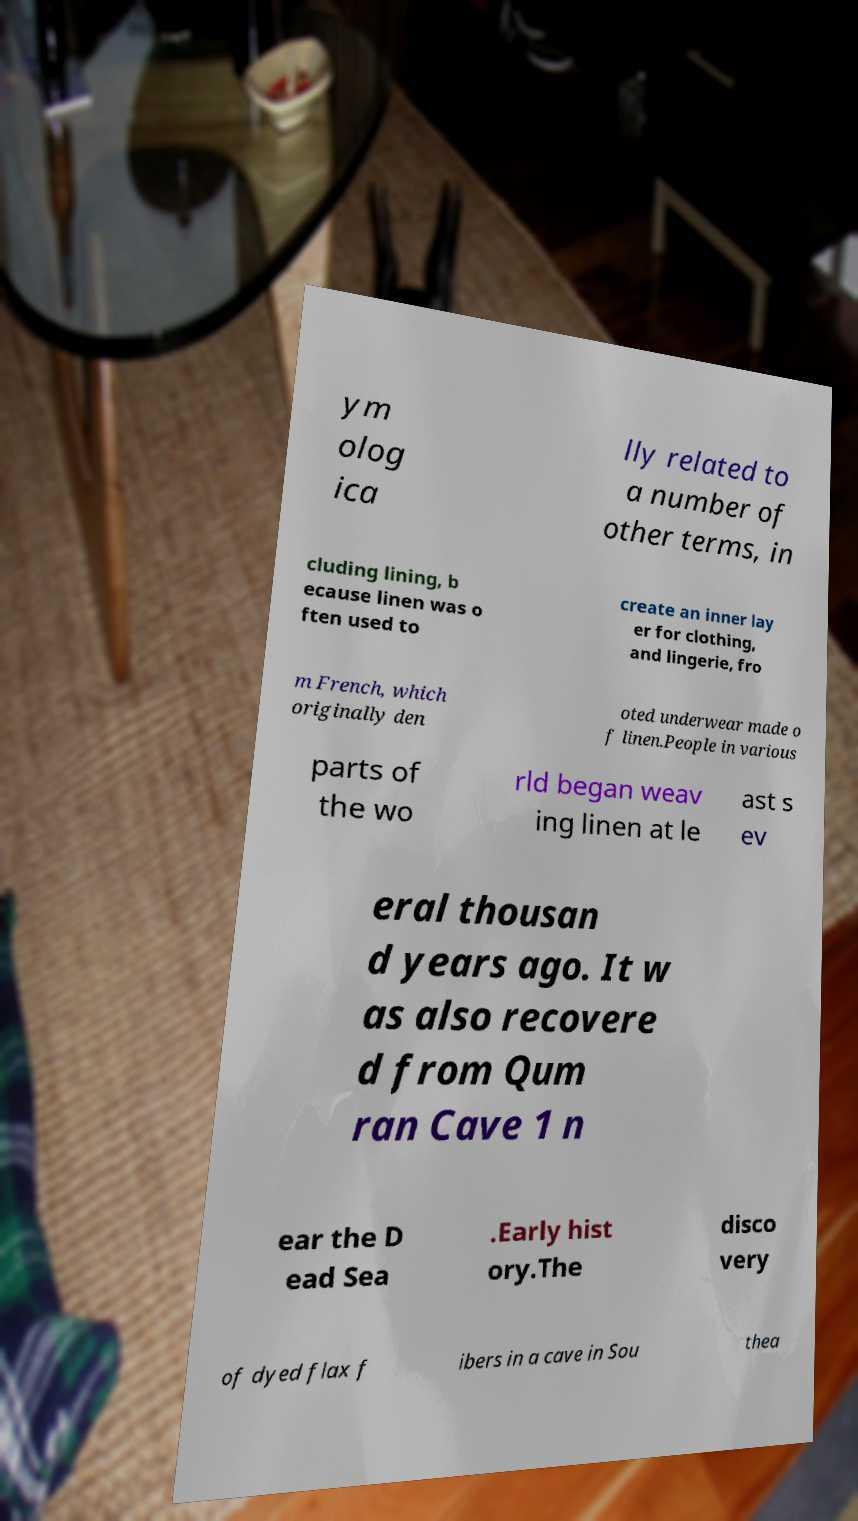Could you extract and type out the text from this image? ym olog ica lly related to a number of other terms, in cluding lining, b ecause linen was o ften used to create an inner lay er for clothing, and lingerie, fro m French, which originally den oted underwear made o f linen.People in various parts of the wo rld began weav ing linen at le ast s ev eral thousan d years ago. It w as also recovere d from Qum ran Cave 1 n ear the D ead Sea .Early hist ory.The disco very of dyed flax f ibers in a cave in Sou thea 